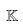<formula> <loc_0><loc_0><loc_500><loc_500>\mathbb { K }</formula> 